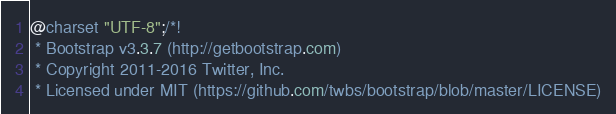Convert code to text. <code><loc_0><loc_0><loc_500><loc_500><_CSS_>@charset "UTF-8";/*!
 * Bootstrap v3.3.7 (http://getbootstrap.com)
 * Copyright 2011-2016 Twitter, Inc.
 * Licensed under MIT (https://github.com/twbs/bootstrap/blob/master/LICENSE)</code> 